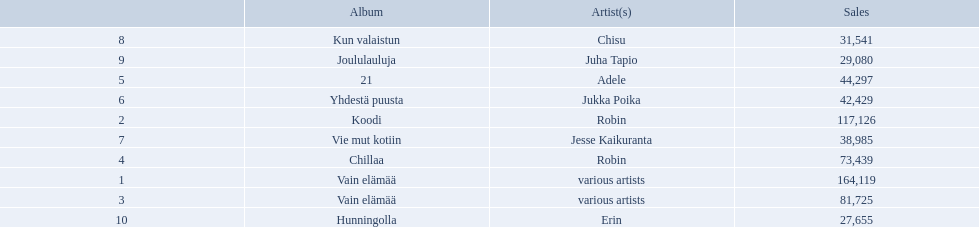What are all the album titles? Vain elämää, Koodi, Vain elämää, Chillaa, 21, Yhdestä puusta, Vie mut kotiin, Kun valaistun, Joululauluja, Hunningolla. Which artists were on the albums? Various artists, robin, various artists, robin, adele, jukka poika, jesse kaikuranta, chisu, juha tapio, erin. Along with chillaa, which other album featured robin? Koodi. 